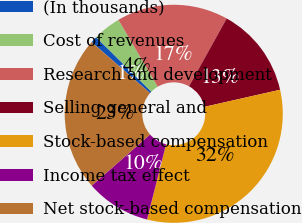Convert chart. <chart><loc_0><loc_0><loc_500><loc_500><pie_chart><fcel>(In thousands)<fcel>Cost of revenues<fcel>Research and development<fcel>Selling general and<fcel>Stock-based compensation<fcel>Income tax effect<fcel>Net stock-based compensation<nl><fcel>0.98%<fcel>4.13%<fcel>16.54%<fcel>13.39%<fcel>32.48%<fcel>9.61%<fcel>22.87%<nl></chart> 